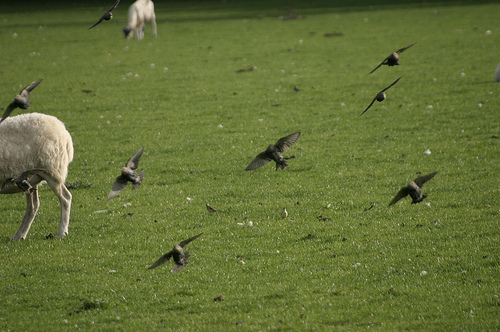Please provide the bounding box coordinate of the region this sentence describes: The bird is airborne. Approximately in the area [0.21, 0.44, 0.33, 0.58], there is a bird captured in mid-air, wings actively flapping. 